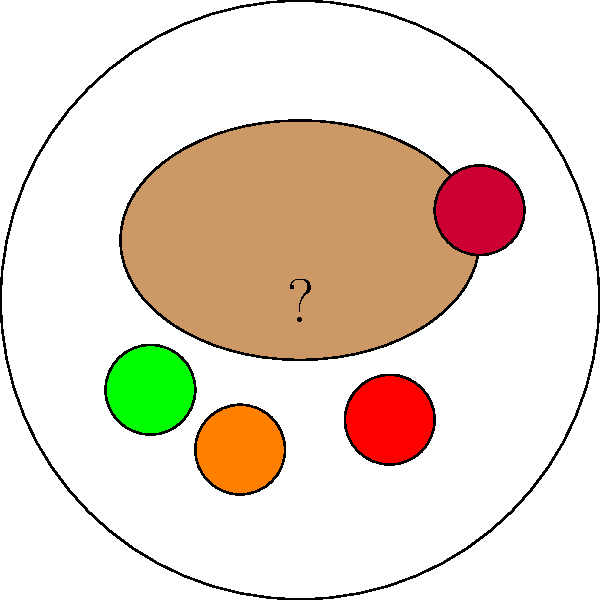In the image segmentation task for identifying components of a festive meal, what is the most likely food item represented by the large brown oval shape in the center of the plate? To identify the components of this festive meal, let's analyze the image step-by-step:

1. We see a circular white shape, which represents a plate.

2. In the center of the plate, there's a large brown oval shape. This is the main dish of the meal.

3. Around the main dish, we see smaller circular shapes in different colors:
   - Green: likely representing a vegetable like peas or Brussels sprouts
   - Orange: possibly carrots or sweet potatoes
   - Red: could be tomatoes or another red vegetable
   - Dark red: likely cranberry sauce, a common accompaniment to festive meals

4. The large brown oval shape in the center is the key element of this meal. In many Western cultures, particularly in the United States, the centerpiece of a festive meal (especially for holidays like Thanksgiving or Christmas) is often a roasted turkey.

5. The shape and color of this central item are consistent with how a roasted turkey would appear on a plate - oval-shaped and brown from roasting.

Therefore, based on the context of a "festive meal" and the visual representation, the most likely food item represented by the large brown oval shape is a roasted turkey.
Answer: Turkey 